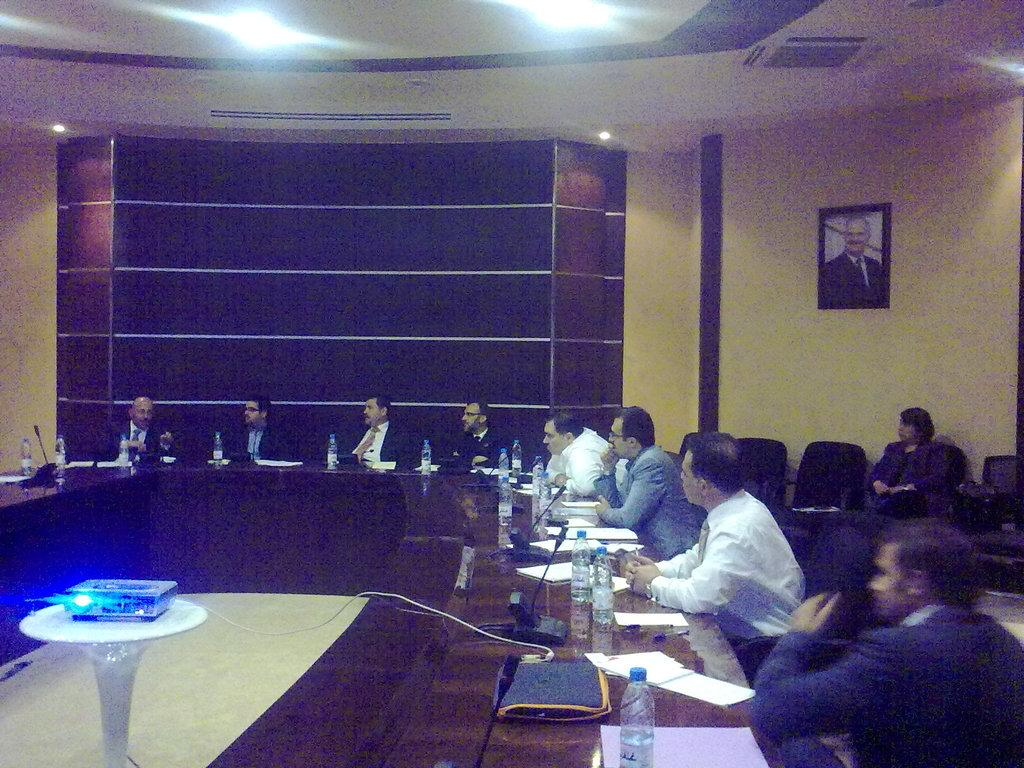What is the main subject of the image? The main subject of the image is a group of men. What are the men doing in the image? The men are sitting at a table and engaged in a discussion. What type of snake can be seen slithering across the island in the image? There is no snake or island present in the image; it features a group of men sitting at a table and engaged in a discussion. 